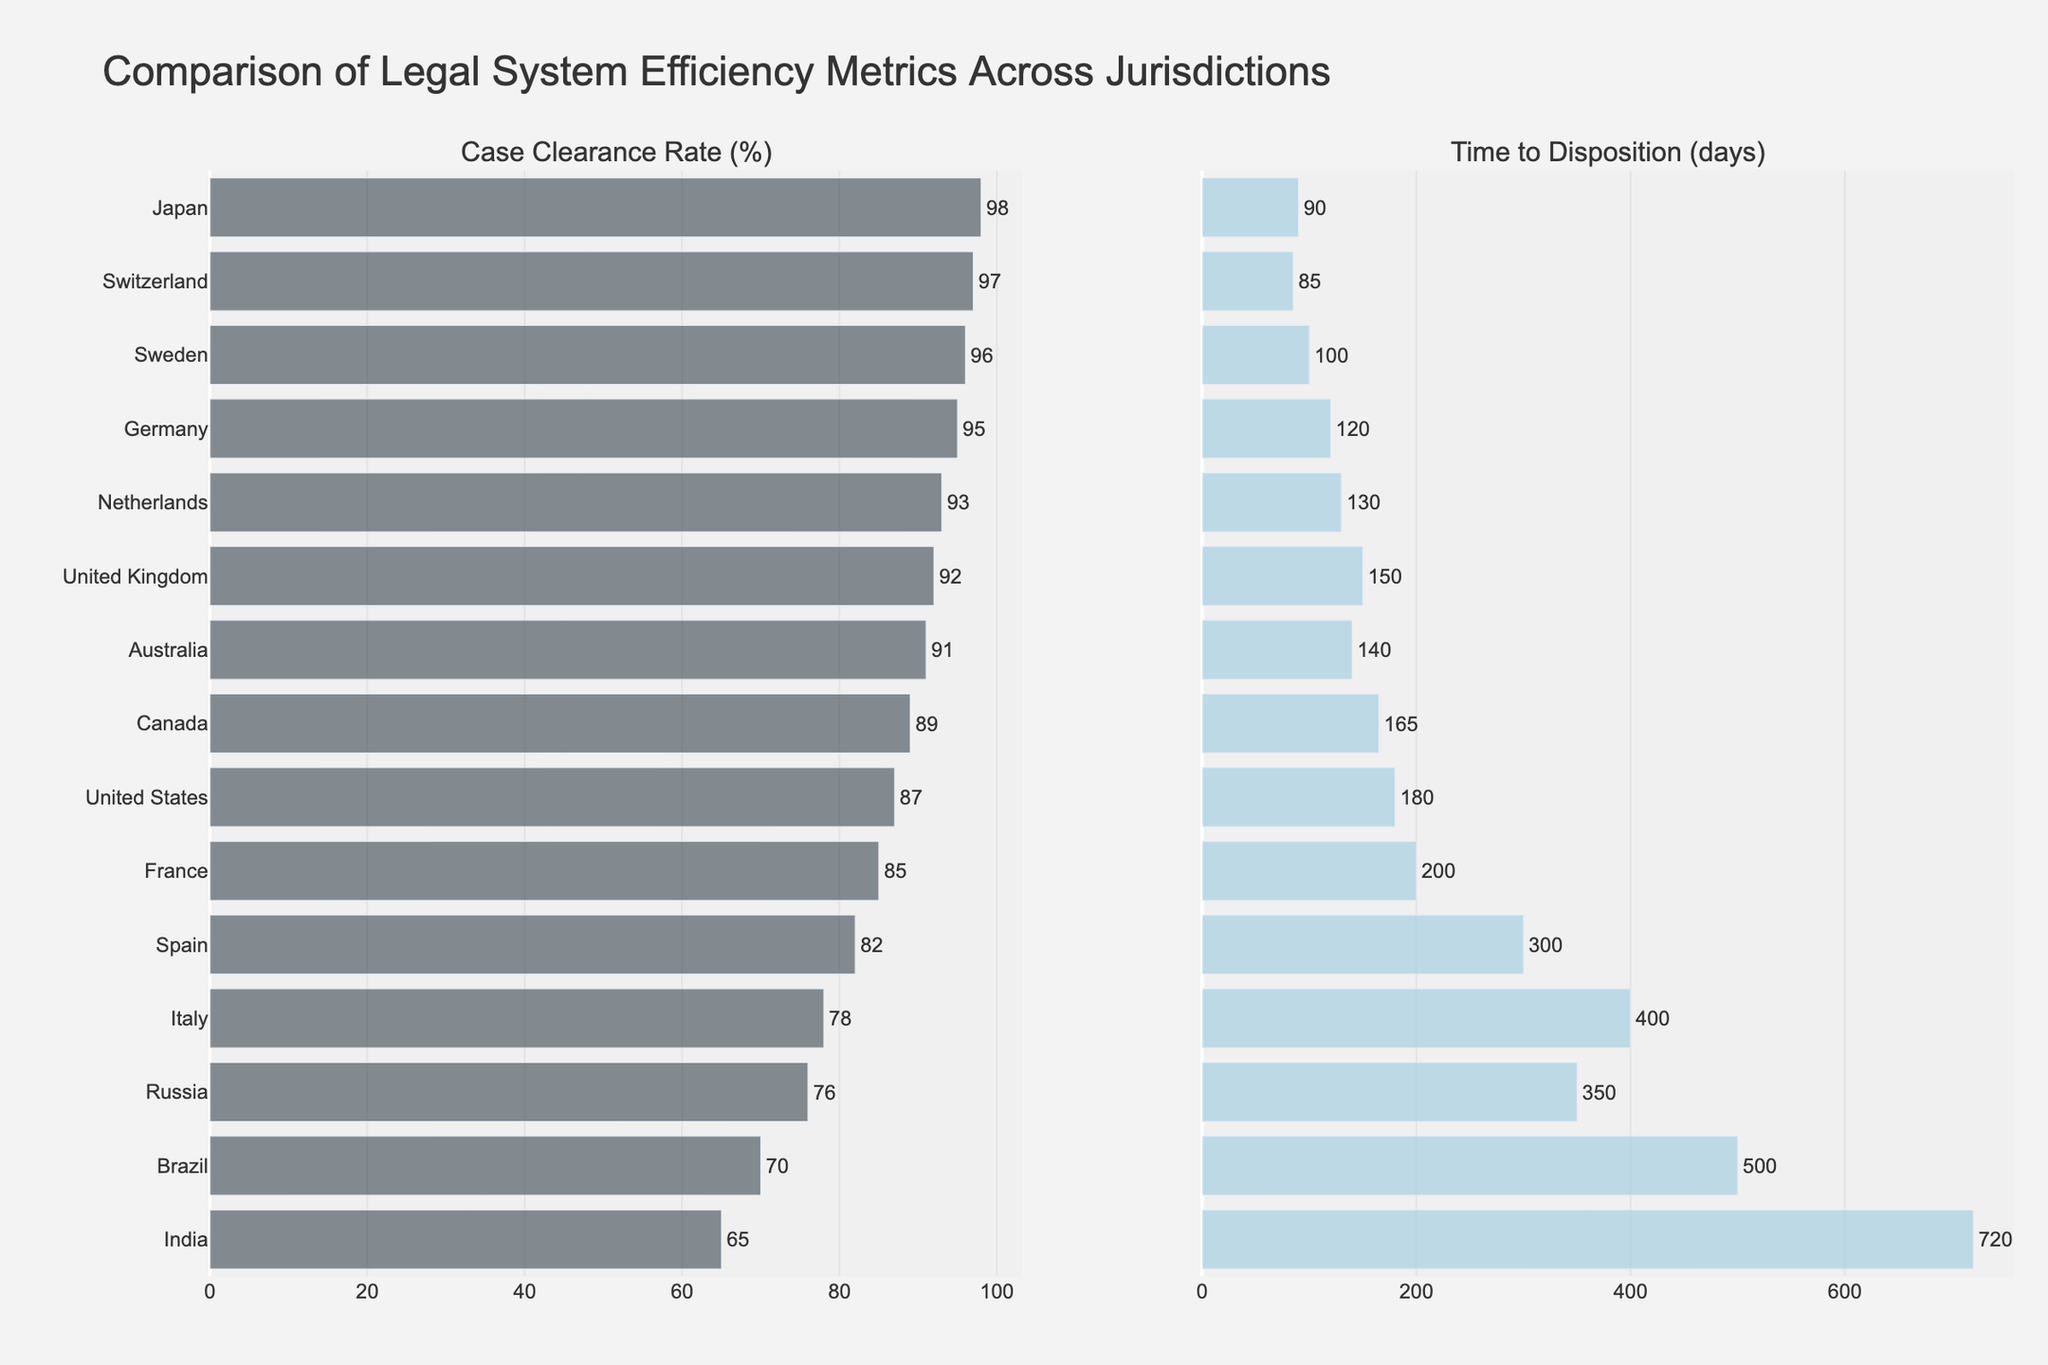What jurisdiction has the highest case clearance rate? By identifying the jurisdiction with the tallest bar in the "Case Clearance Rate (%)" subplot, Japan has the highest case clearance rate of 98%.
Answer: Japan Which jurisdiction has the longest time to disposition? By identifying the jurisdiction with the longest bar in the "Time to Disposition (days)" subplot, India has the longest time to disposition at 720 days.
Answer: India Which two jurisdictions have the closest case clearance rates? Comparing the bar lengths in the "Case Clearance Rate (%)" subplot, the United Kingdom and Netherlands have closely matched case clearance rates of 92% and 93%, respectively.
Answer: United Kingdom and Netherlands What is the difference in time to disposition between Sweden and the United Kingdom? The time to disposition for Sweden is 100 days, and for the United Kingdom is 150 days. The difference is 150 - 100 = 50 days.
Answer: 50 days Rank the top three jurisdictions by case clearance rate and provide their rates. By visually comparing the bars in the "Case Clearance Rate (%)" subplot, the top three jurisdictions are Japan (98%), Switzerland (97%), and Sweden (96%).
Answer: Japan (98%), Switzerland (97%), and Sweden (96%) Is there a correlation between case clearance rate and time to disposition? Observing the length of the bars in both subplots, jurisdictions with high case clearance rates tend to have shorter times to disposition. For example, Japan has a high clearance rate (98%) and a short disposition time (90 days).
Answer: Yes Which jurisdiction has the lowest case clearance rate, and what is its rate? By identifying the jurisdiction with the shortest bar in the "Case Clearance Rate (%)" subplot, India has the lowest case clearance rate of 65%.
Answer: India How does France's case clearance rate compare to its time to disposition? France's case clearance rate and time to disposition can be compared by examining the respective lengths of the bars. France has a clearance rate of 85% and a time to disposition of 200 days, indicating a moderately efficient clearance rate but a longer disposition time.
Answer: 85% clearance rate, 200 days What is the average case clearance rate for all jurisdictions? Sum the case clearance rates and divide by the number of jurisdictions: (87 + 95 + 98 + 92 + 89 + 91 + 85 + 96 + 93 + 97 + 78 + 82 + 70 + 76 + 65) / 15 = 86%.
Answer: 86% What is the median time to disposition across all jurisdictions? Sorting the times to disposition yields: 85, 90, 100, 120, 130, 140, 150, 165, 180, 200, 300, 350, 400, 500, 720. The middle value (8th in the sorted list) is 165 days.
Answer: 165 days 